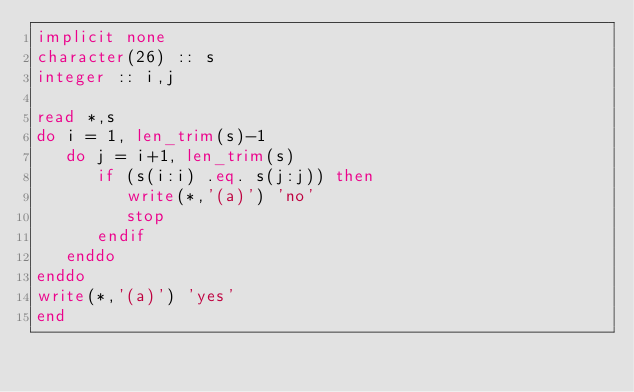<code> <loc_0><loc_0><loc_500><loc_500><_FORTRAN_>implicit none
character(26) :: s
integer :: i,j

read *,s
do i = 1, len_trim(s)-1
   do j = i+1, len_trim(s)
      if (s(i:i) .eq. s(j:j)) then
         write(*,'(a)') 'no'
         stop
      endif
   enddo
enddo
write(*,'(a)') 'yes'
end</code> 